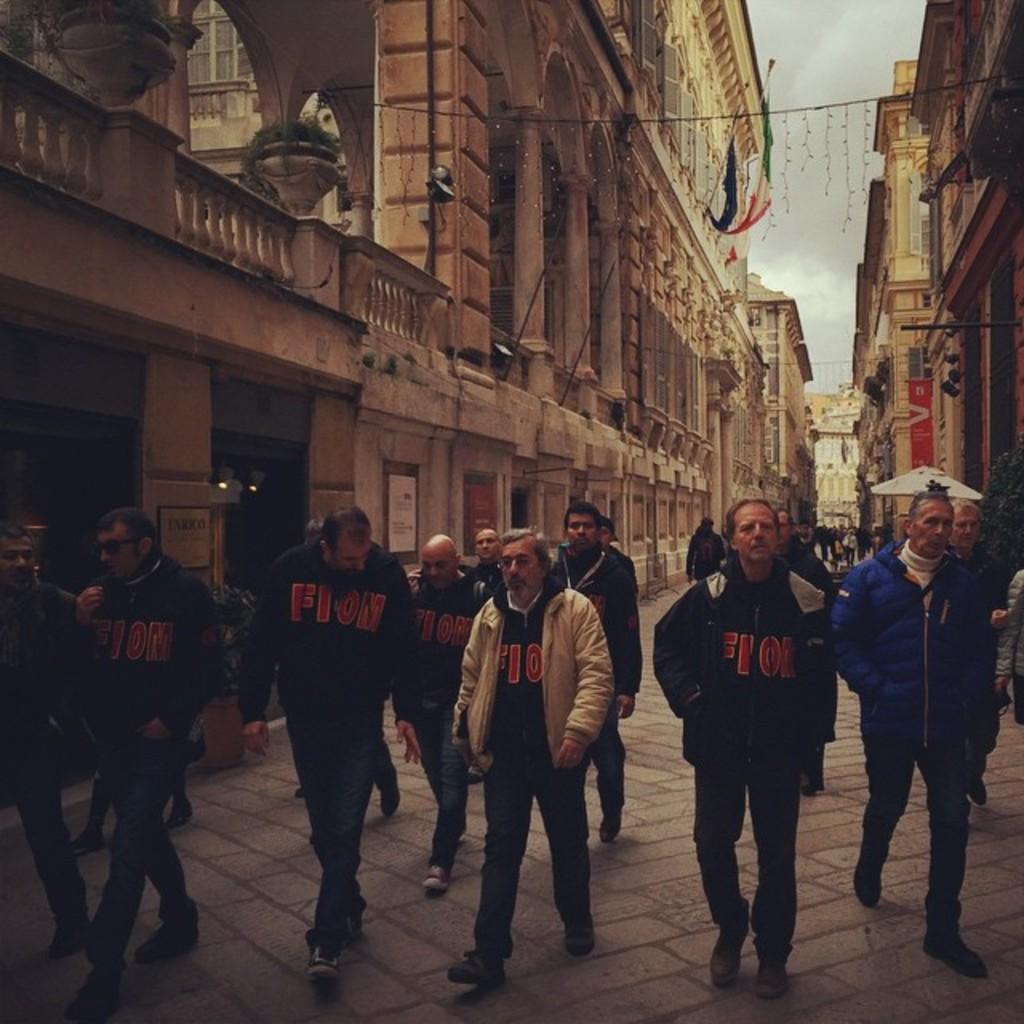Could you give a brief overview of what you see in this image? In this image we can see a group of people walking on the path. One person is wearing a white coat with spectacle. To the right side of the image we can see a person wearing a blue coat. In the background, we can see a group of buildings, flags, plants and the sky. 